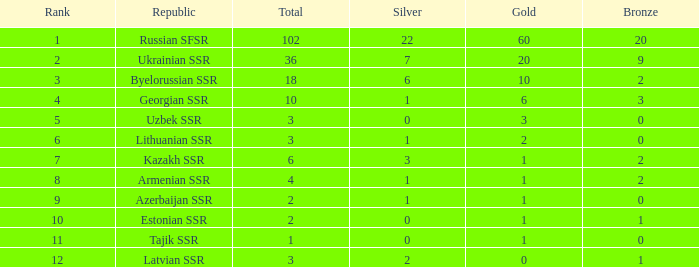What is the total number of bronzes associated with 1 silver, ranks under 6 and under 6 golds? None. 